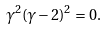<formula> <loc_0><loc_0><loc_500><loc_500>\gamma ^ { 2 } ( \gamma - 2 ) ^ { 2 } = 0 .</formula> 